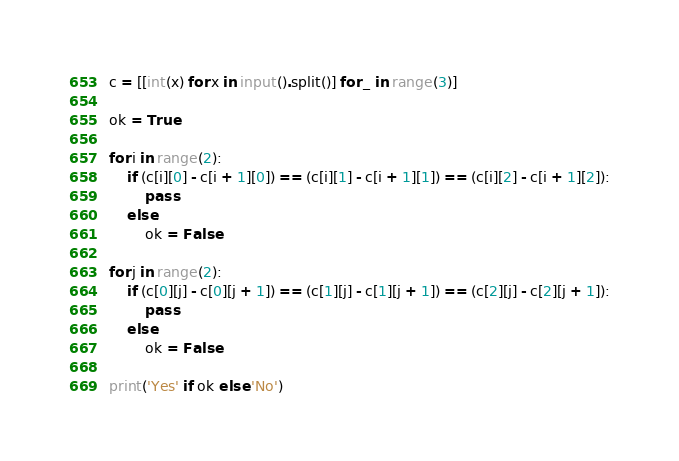<code> <loc_0><loc_0><loc_500><loc_500><_Python_>c = [[int(x) for x in input().split()] for _ in range(3)]

ok = True

for i in range(2):
    if (c[i][0] - c[i + 1][0]) == (c[i][1] - c[i + 1][1]) == (c[i][2] - c[i + 1][2]):
        pass
    else:
        ok = False

for j in range(2):
    if (c[0][j] - c[0][j + 1]) == (c[1][j] - c[1][j + 1]) == (c[2][j] - c[2][j + 1]):
        pass
    else:
        ok = False

print('Yes' if ok else 'No')
</code> 